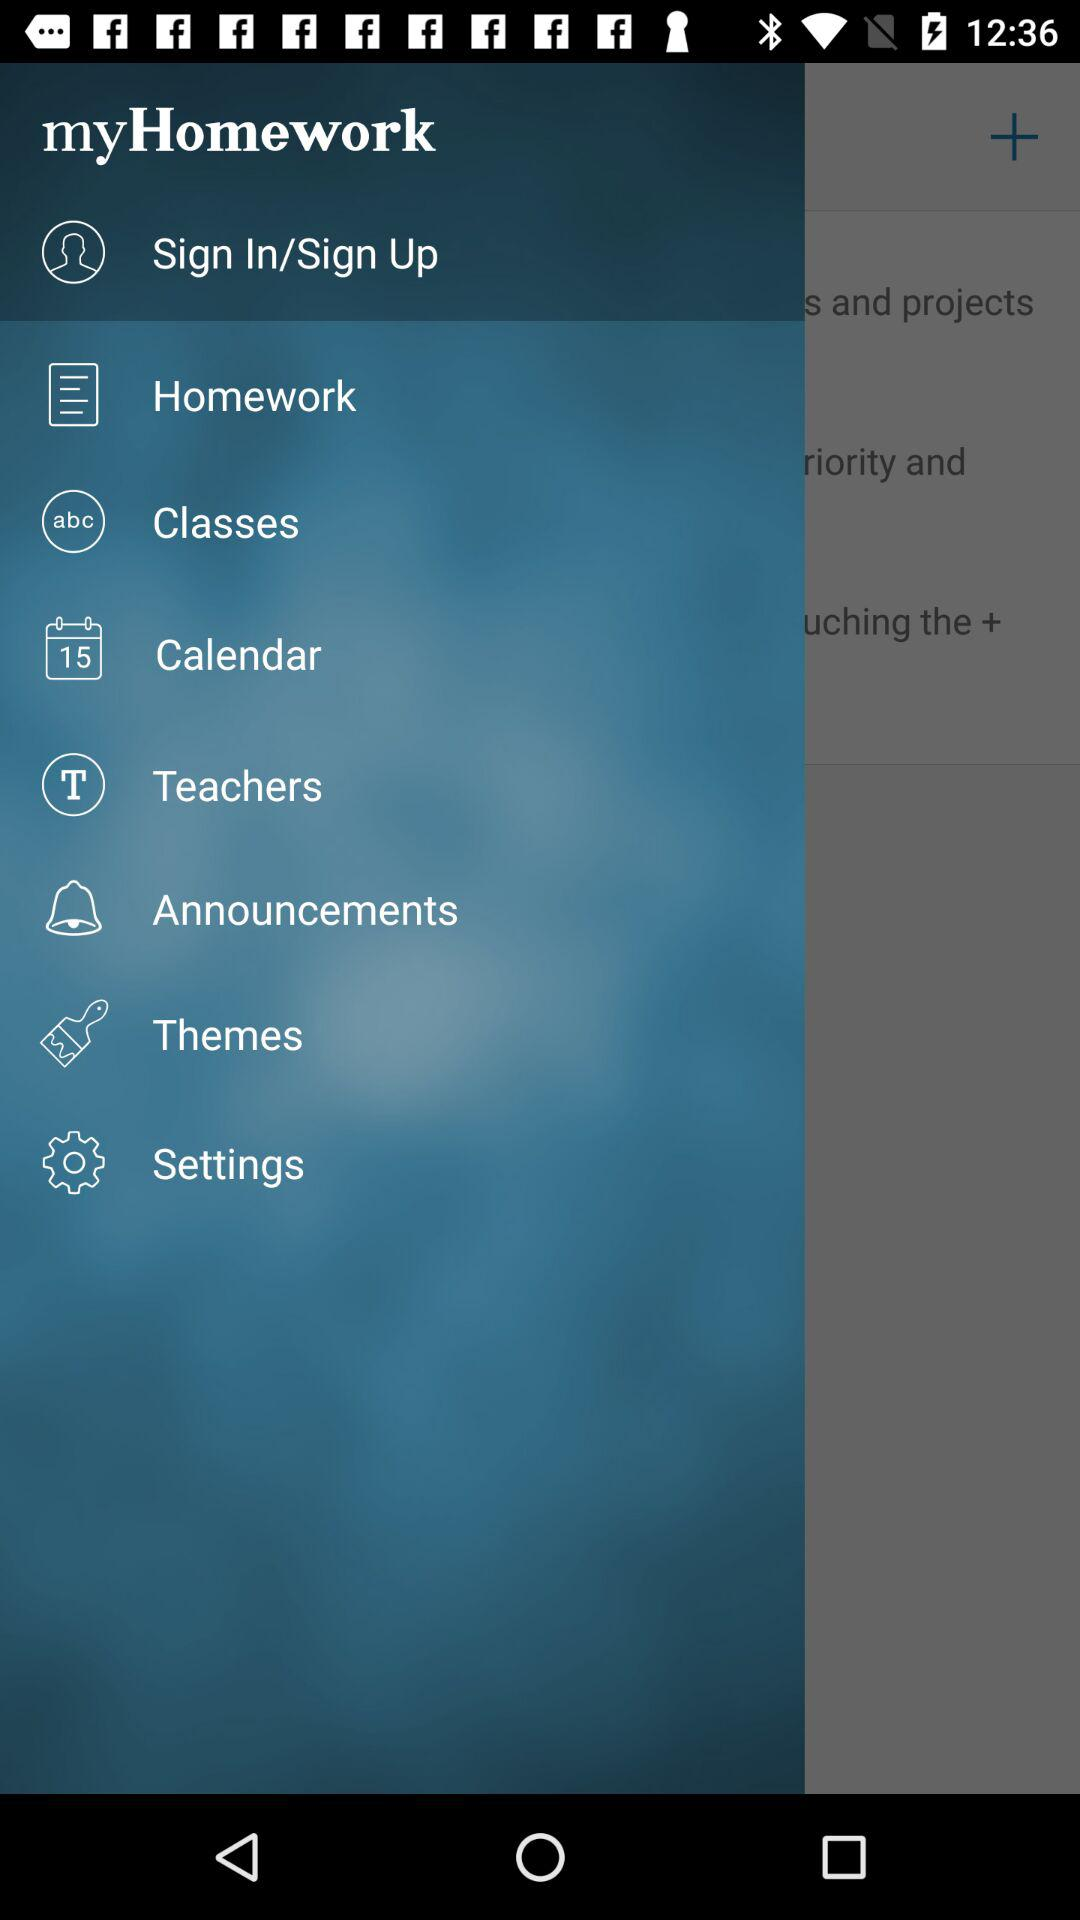What is the name of the application? The name of the application is "myHomework". 